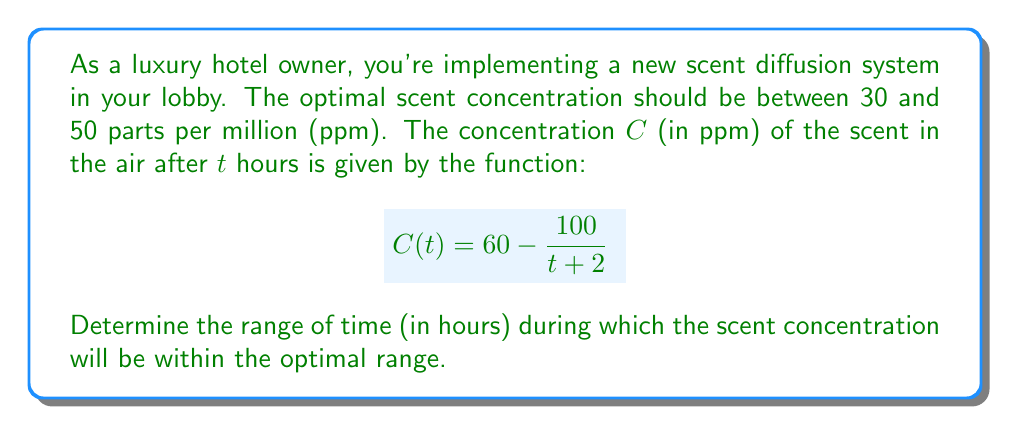Solve this math problem. To solve this problem, we need to find the values of $t$ that satisfy the inequality:

$$30 \leq C(t) \leq 50$$

Substituting the given function:

$$30 \leq 60 - \frac{100}{t+2} \leq 50$$

Let's solve each part of the inequality separately:

1) For the left side: $30 \leq 60 - \frac{100}{t+2}$
   
   Subtracting 60 from both sides:
   $$-30 \leq - \frac{100}{t+2}$$
   
   Multiplying both sides by -1 (and flipping the inequality sign):
   $$30 \geq \frac{100}{t+2}$$
   
   Dividing both sides by 30:
   $$1 \geq \frac{10/3}{t+2}$$
   
   Reciprocating both sides (and flipping the inequality sign):
   $$1 \leq \frac{t+2}{10/3}$$
   
   Multiplying both sides by 10/3:
   $$10/3 \leq t+2$$
   
   Subtracting 2 from both sides:
   $$1/3 \leq t$$

2) For the right side: $60 - \frac{100}{t+2} \leq 50$
   
   Subtracting 60 from both sides:
   $$- \frac{100}{t+2} \leq -10$$
   
   Multiplying both sides by -1 (and flipping the inequality sign):
   $$\frac{100}{t+2} \geq 10$$
   
   Dividing both sides by 10:
   $$\frac{10}{t+2} \geq 1$$
   
   Reciprocating both sides (and flipping the inequality sign):
   $$t+2 \geq 10$$
   
   Subtracting 2 from both sides:
   $$t \geq 8$$

Combining the results from steps 1 and 2, we get:

$$8 \leq t \leq \infty$$

Therefore, the optimal concentration range is maintained from 8 hours onwards after the system is turned on.
Answer: The scent concentration will be within the optimal range for all times $t \geq 8$ hours. 